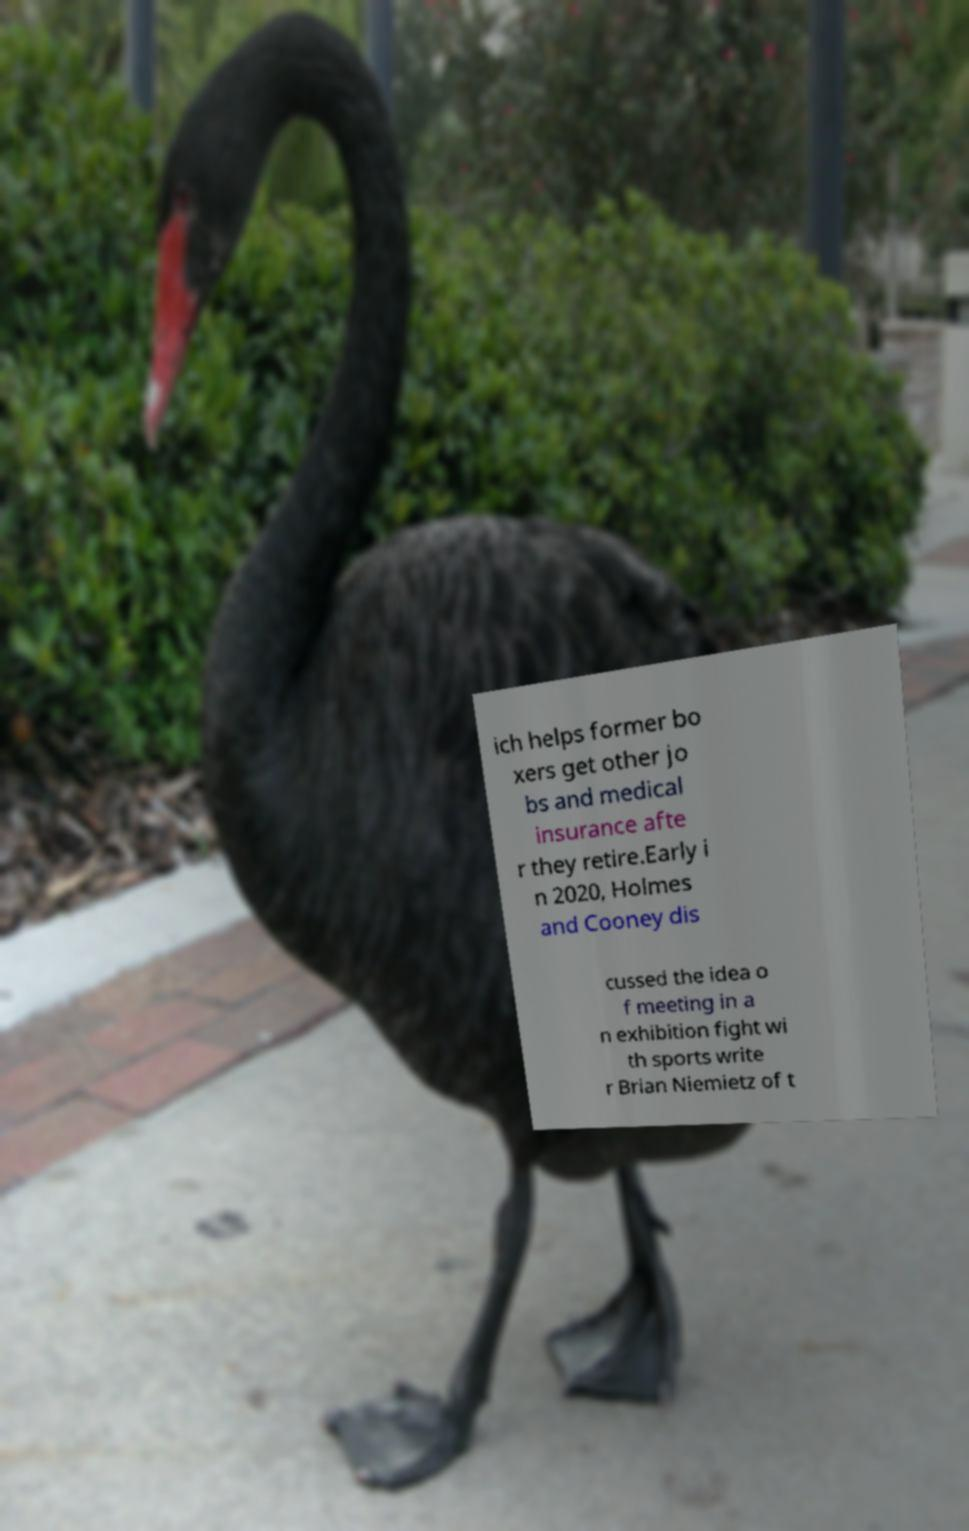Could you extract and type out the text from this image? ich helps former bo xers get other jo bs and medical insurance afte r they retire.Early i n 2020, Holmes and Cooney dis cussed the idea o f meeting in a n exhibition fight wi th sports write r Brian Niemietz of t 